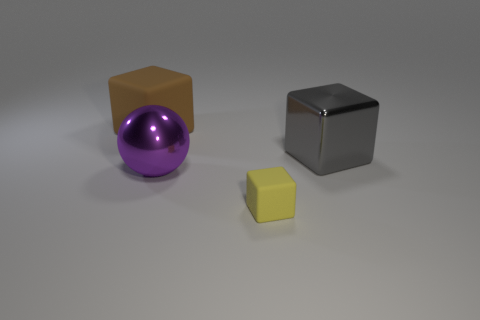The matte object that is in front of the big metal thing left of the tiny cube is what color?
Offer a very short reply. Yellow. Is there any other thing that has the same size as the gray metal cube?
Ensure brevity in your answer.  Yes. There is a matte object right of the big matte block; is it the same shape as the brown matte object?
Provide a succinct answer. Yes. What number of big objects are to the left of the big gray metallic object and to the right of the large brown block?
Your answer should be compact. 1. What is the color of the cube right of the matte cube that is in front of the cube behind the gray metal block?
Your response must be concise. Gray. There is a large block in front of the large brown block; what number of purple objects are behind it?
Your response must be concise. 0. What number of other objects are the same shape as the tiny yellow rubber object?
Your answer should be compact. 2. What number of things are big rubber cubes or rubber objects that are on the left side of the tiny object?
Ensure brevity in your answer.  1. Are there more metal balls that are behind the large purple metallic thing than big cubes left of the large gray object?
Your answer should be very brief. No. The metallic thing to the left of the shiny thing that is on the right side of the rubber cube in front of the large gray metallic thing is what shape?
Your response must be concise. Sphere. 